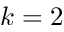<formula> <loc_0><loc_0><loc_500><loc_500>k = 2</formula> 